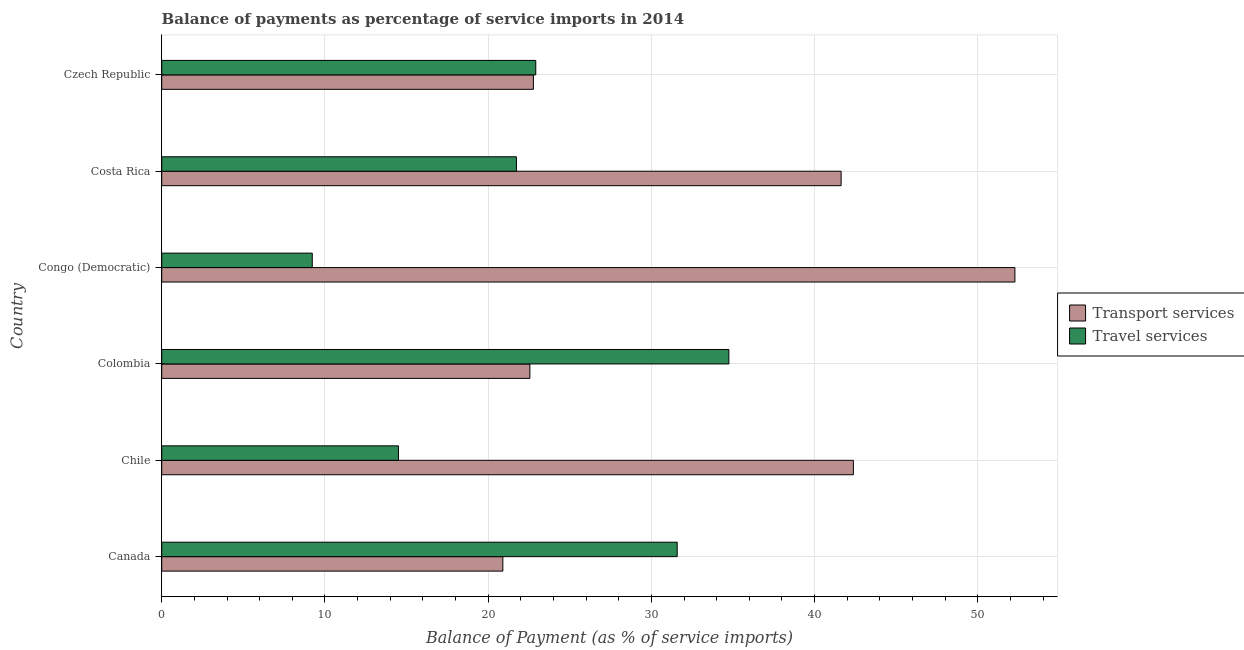How many different coloured bars are there?
Provide a short and direct response. 2. How many groups of bars are there?
Provide a short and direct response. 6. Are the number of bars on each tick of the Y-axis equal?
Offer a terse response. Yes. How many bars are there on the 6th tick from the bottom?
Your response must be concise. 2. In how many cases, is the number of bars for a given country not equal to the number of legend labels?
Offer a very short reply. 0. What is the balance of payments of transport services in Costa Rica?
Make the answer very short. 41.63. Across all countries, what is the maximum balance of payments of travel services?
Your answer should be very brief. 34.75. Across all countries, what is the minimum balance of payments of transport services?
Your answer should be very brief. 20.9. In which country was the balance of payments of transport services maximum?
Your response must be concise. Congo (Democratic). In which country was the balance of payments of transport services minimum?
Make the answer very short. Canada. What is the total balance of payments of transport services in the graph?
Provide a succinct answer. 202.5. What is the difference between the balance of payments of travel services in Chile and that in Colombia?
Keep it short and to the point. -20.24. What is the difference between the balance of payments of transport services in Costa Rica and the balance of payments of travel services in Chile?
Your answer should be compact. 27.12. What is the average balance of payments of transport services per country?
Your response must be concise. 33.75. What is the difference between the balance of payments of travel services and balance of payments of transport services in Congo (Democratic)?
Your answer should be very brief. -43.05. What is the ratio of the balance of payments of transport services in Canada to that in Czech Republic?
Your answer should be compact. 0.92. What is the difference between the highest and the second highest balance of payments of travel services?
Keep it short and to the point. 3.17. What is the difference between the highest and the lowest balance of payments of transport services?
Give a very brief answer. 31.37. Is the sum of the balance of payments of travel services in Canada and Colombia greater than the maximum balance of payments of transport services across all countries?
Offer a terse response. Yes. What does the 2nd bar from the top in Costa Rica represents?
Keep it short and to the point. Transport services. What does the 1st bar from the bottom in Canada represents?
Provide a succinct answer. Transport services. Are all the bars in the graph horizontal?
Your answer should be compact. Yes. How many countries are there in the graph?
Provide a short and direct response. 6. Are the values on the major ticks of X-axis written in scientific E-notation?
Give a very brief answer. No. Does the graph contain any zero values?
Your response must be concise. No. Does the graph contain grids?
Provide a succinct answer. Yes. How are the legend labels stacked?
Give a very brief answer. Vertical. What is the title of the graph?
Offer a terse response. Balance of payments as percentage of service imports in 2014. Does "Unregistered firms" appear as one of the legend labels in the graph?
Ensure brevity in your answer.  No. What is the label or title of the X-axis?
Offer a terse response. Balance of Payment (as % of service imports). What is the Balance of Payment (as % of service imports) of Transport services in Canada?
Keep it short and to the point. 20.9. What is the Balance of Payment (as % of service imports) of Travel services in Canada?
Your answer should be compact. 31.58. What is the Balance of Payment (as % of service imports) of Transport services in Chile?
Your answer should be very brief. 42.38. What is the Balance of Payment (as % of service imports) of Travel services in Chile?
Your response must be concise. 14.5. What is the Balance of Payment (as % of service imports) in Transport services in Colombia?
Give a very brief answer. 22.56. What is the Balance of Payment (as % of service imports) of Travel services in Colombia?
Provide a succinct answer. 34.75. What is the Balance of Payment (as % of service imports) of Transport services in Congo (Democratic)?
Offer a terse response. 52.27. What is the Balance of Payment (as % of service imports) of Travel services in Congo (Democratic)?
Make the answer very short. 9.22. What is the Balance of Payment (as % of service imports) of Transport services in Costa Rica?
Offer a very short reply. 41.63. What is the Balance of Payment (as % of service imports) in Travel services in Costa Rica?
Your answer should be compact. 21.73. What is the Balance of Payment (as % of service imports) in Transport services in Czech Republic?
Offer a very short reply. 22.77. What is the Balance of Payment (as % of service imports) of Travel services in Czech Republic?
Make the answer very short. 22.92. Across all countries, what is the maximum Balance of Payment (as % of service imports) of Transport services?
Offer a terse response. 52.27. Across all countries, what is the maximum Balance of Payment (as % of service imports) of Travel services?
Your response must be concise. 34.75. Across all countries, what is the minimum Balance of Payment (as % of service imports) in Transport services?
Keep it short and to the point. 20.9. Across all countries, what is the minimum Balance of Payment (as % of service imports) of Travel services?
Your answer should be compact. 9.22. What is the total Balance of Payment (as % of service imports) in Transport services in the graph?
Offer a very short reply. 202.5. What is the total Balance of Payment (as % of service imports) of Travel services in the graph?
Provide a succinct answer. 134.71. What is the difference between the Balance of Payment (as % of service imports) of Transport services in Canada and that in Chile?
Make the answer very short. -21.48. What is the difference between the Balance of Payment (as % of service imports) in Travel services in Canada and that in Chile?
Make the answer very short. 17.08. What is the difference between the Balance of Payment (as % of service imports) in Transport services in Canada and that in Colombia?
Provide a short and direct response. -1.66. What is the difference between the Balance of Payment (as % of service imports) of Travel services in Canada and that in Colombia?
Your answer should be very brief. -3.17. What is the difference between the Balance of Payment (as % of service imports) of Transport services in Canada and that in Congo (Democratic)?
Make the answer very short. -31.37. What is the difference between the Balance of Payment (as % of service imports) of Travel services in Canada and that in Congo (Democratic)?
Offer a terse response. 22.36. What is the difference between the Balance of Payment (as % of service imports) in Transport services in Canada and that in Costa Rica?
Give a very brief answer. -20.73. What is the difference between the Balance of Payment (as % of service imports) of Travel services in Canada and that in Costa Rica?
Your answer should be compact. 9.85. What is the difference between the Balance of Payment (as % of service imports) in Transport services in Canada and that in Czech Republic?
Give a very brief answer. -1.87. What is the difference between the Balance of Payment (as % of service imports) in Travel services in Canada and that in Czech Republic?
Provide a succinct answer. 8.66. What is the difference between the Balance of Payment (as % of service imports) in Transport services in Chile and that in Colombia?
Keep it short and to the point. 19.82. What is the difference between the Balance of Payment (as % of service imports) in Travel services in Chile and that in Colombia?
Your response must be concise. -20.24. What is the difference between the Balance of Payment (as % of service imports) in Transport services in Chile and that in Congo (Democratic)?
Give a very brief answer. -9.9. What is the difference between the Balance of Payment (as % of service imports) in Travel services in Chile and that in Congo (Democratic)?
Your answer should be very brief. 5.28. What is the difference between the Balance of Payment (as % of service imports) in Transport services in Chile and that in Costa Rica?
Keep it short and to the point. 0.75. What is the difference between the Balance of Payment (as % of service imports) of Travel services in Chile and that in Costa Rica?
Offer a very short reply. -7.23. What is the difference between the Balance of Payment (as % of service imports) in Transport services in Chile and that in Czech Republic?
Offer a very short reply. 19.6. What is the difference between the Balance of Payment (as % of service imports) of Travel services in Chile and that in Czech Republic?
Provide a succinct answer. -8.41. What is the difference between the Balance of Payment (as % of service imports) in Transport services in Colombia and that in Congo (Democratic)?
Offer a terse response. -29.72. What is the difference between the Balance of Payment (as % of service imports) of Travel services in Colombia and that in Congo (Democratic)?
Make the answer very short. 25.52. What is the difference between the Balance of Payment (as % of service imports) in Transport services in Colombia and that in Costa Rica?
Your answer should be compact. -19.07. What is the difference between the Balance of Payment (as % of service imports) in Travel services in Colombia and that in Costa Rica?
Give a very brief answer. 13.02. What is the difference between the Balance of Payment (as % of service imports) of Transport services in Colombia and that in Czech Republic?
Provide a short and direct response. -0.22. What is the difference between the Balance of Payment (as % of service imports) in Travel services in Colombia and that in Czech Republic?
Your answer should be compact. 11.83. What is the difference between the Balance of Payment (as % of service imports) of Transport services in Congo (Democratic) and that in Costa Rica?
Give a very brief answer. 10.65. What is the difference between the Balance of Payment (as % of service imports) in Travel services in Congo (Democratic) and that in Costa Rica?
Your answer should be very brief. -12.51. What is the difference between the Balance of Payment (as % of service imports) in Transport services in Congo (Democratic) and that in Czech Republic?
Your answer should be very brief. 29.5. What is the difference between the Balance of Payment (as % of service imports) in Travel services in Congo (Democratic) and that in Czech Republic?
Your answer should be very brief. -13.69. What is the difference between the Balance of Payment (as % of service imports) of Transport services in Costa Rica and that in Czech Republic?
Keep it short and to the point. 18.85. What is the difference between the Balance of Payment (as % of service imports) of Travel services in Costa Rica and that in Czech Republic?
Make the answer very short. -1.18. What is the difference between the Balance of Payment (as % of service imports) of Transport services in Canada and the Balance of Payment (as % of service imports) of Travel services in Chile?
Make the answer very short. 6.4. What is the difference between the Balance of Payment (as % of service imports) in Transport services in Canada and the Balance of Payment (as % of service imports) in Travel services in Colombia?
Your answer should be compact. -13.85. What is the difference between the Balance of Payment (as % of service imports) of Transport services in Canada and the Balance of Payment (as % of service imports) of Travel services in Congo (Democratic)?
Provide a succinct answer. 11.68. What is the difference between the Balance of Payment (as % of service imports) of Transport services in Canada and the Balance of Payment (as % of service imports) of Travel services in Costa Rica?
Keep it short and to the point. -0.83. What is the difference between the Balance of Payment (as % of service imports) in Transport services in Canada and the Balance of Payment (as % of service imports) in Travel services in Czech Republic?
Provide a short and direct response. -2.02. What is the difference between the Balance of Payment (as % of service imports) in Transport services in Chile and the Balance of Payment (as % of service imports) in Travel services in Colombia?
Provide a short and direct response. 7.63. What is the difference between the Balance of Payment (as % of service imports) of Transport services in Chile and the Balance of Payment (as % of service imports) of Travel services in Congo (Democratic)?
Your answer should be very brief. 33.15. What is the difference between the Balance of Payment (as % of service imports) in Transport services in Chile and the Balance of Payment (as % of service imports) in Travel services in Costa Rica?
Offer a very short reply. 20.64. What is the difference between the Balance of Payment (as % of service imports) in Transport services in Chile and the Balance of Payment (as % of service imports) in Travel services in Czech Republic?
Your answer should be very brief. 19.46. What is the difference between the Balance of Payment (as % of service imports) of Transport services in Colombia and the Balance of Payment (as % of service imports) of Travel services in Congo (Democratic)?
Give a very brief answer. 13.33. What is the difference between the Balance of Payment (as % of service imports) of Transport services in Colombia and the Balance of Payment (as % of service imports) of Travel services in Costa Rica?
Provide a short and direct response. 0.82. What is the difference between the Balance of Payment (as % of service imports) of Transport services in Colombia and the Balance of Payment (as % of service imports) of Travel services in Czech Republic?
Make the answer very short. -0.36. What is the difference between the Balance of Payment (as % of service imports) in Transport services in Congo (Democratic) and the Balance of Payment (as % of service imports) in Travel services in Costa Rica?
Give a very brief answer. 30.54. What is the difference between the Balance of Payment (as % of service imports) in Transport services in Congo (Democratic) and the Balance of Payment (as % of service imports) in Travel services in Czech Republic?
Offer a very short reply. 29.36. What is the difference between the Balance of Payment (as % of service imports) in Transport services in Costa Rica and the Balance of Payment (as % of service imports) in Travel services in Czech Republic?
Give a very brief answer. 18.71. What is the average Balance of Payment (as % of service imports) in Transport services per country?
Your answer should be compact. 33.75. What is the average Balance of Payment (as % of service imports) of Travel services per country?
Your answer should be very brief. 22.45. What is the difference between the Balance of Payment (as % of service imports) in Transport services and Balance of Payment (as % of service imports) in Travel services in Canada?
Give a very brief answer. -10.68. What is the difference between the Balance of Payment (as % of service imports) of Transport services and Balance of Payment (as % of service imports) of Travel services in Chile?
Make the answer very short. 27.87. What is the difference between the Balance of Payment (as % of service imports) of Transport services and Balance of Payment (as % of service imports) of Travel services in Colombia?
Offer a very short reply. -12.19. What is the difference between the Balance of Payment (as % of service imports) in Transport services and Balance of Payment (as % of service imports) in Travel services in Congo (Democratic)?
Offer a very short reply. 43.05. What is the difference between the Balance of Payment (as % of service imports) in Transport services and Balance of Payment (as % of service imports) in Travel services in Costa Rica?
Your answer should be compact. 19.89. What is the difference between the Balance of Payment (as % of service imports) in Transport services and Balance of Payment (as % of service imports) in Travel services in Czech Republic?
Your answer should be compact. -0.14. What is the ratio of the Balance of Payment (as % of service imports) of Transport services in Canada to that in Chile?
Your answer should be very brief. 0.49. What is the ratio of the Balance of Payment (as % of service imports) in Travel services in Canada to that in Chile?
Offer a terse response. 2.18. What is the ratio of the Balance of Payment (as % of service imports) of Transport services in Canada to that in Colombia?
Give a very brief answer. 0.93. What is the ratio of the Balance of Payment (as % of service imports) of Travel services in Canada to that in Colombia?
Provide a succinct answer. 0.91. What is the ratio of the Balance of Payment (as % of service imports) of Transport services in Canada to that in Congo (Democratic)?
Provide a succinct answer. 0.4. What is the ratio of the Balance of Payment (as % of service imports) of Travel services in Canada to that in Congo (Democratic)?
Your response must be concise. 3.42. What is the ratio of the Balance of Payment (as % of service imports) in Transport services in Canada to that in Costa Rica?
Ensure brevity in your answer.  0.5. What is the ratio of the Balance of Payment (as % of service imports) in Travel services in Canada to that in Costa Rica?
Ensure brevity in your answer.  1.45. What is the ratio of the Balance of Payment (as % of service imports) in Transport services in Canada to that in Czech Republic?
Offer a very short reply. 0.92. What is the ratio of the Balance of Payment (as % of service imports) of Travel services in Canada to that in Czech Republic?
Keep it short and to the point. 1.38. What is the ratio of the Balance of Payment (as % of service imports) in Transport services in Chile to that in Colombia?
Your answer should be compact. 1.88. What is the ratio of the Balance of Payment (as % of service imports) in Travel services in Chile to that in Colombia?
Provide a short and direct response. 0.42. What is the ratio of the Balance of Payment (as % of service imports) in Transport services in Chile to that in Congo (Democratic)?
Make the answer very short. 0.81. What is the ratio of the Balance of Payment (as % of service imports) of Travel services in Chile to that in Congo (Democratic)?
Offer a terse response. 1.57. What is the ratio of the Balance of Payment (as % of service imports) of Transport services in Chile to that in Costa Rica?
Keep it short and to the point. 1.02. What is the ratio of the Balance of Payment (as % of service imports) in Travel services in Chile to that in Costa Rica?
Your answer should be very brief. 0.67. What is the ratio of the Balance of Payment (as % of service imports) in Transport services in Chile to that in Czech Republic?
Keep it short and to the point. 1.86. What is the ratio of the Balance of Payment (as % of service imports) in Travel services in Chile to that in Czech Republic?
Make the answer very short. 0.63. What is the ratio of the Balance of Payment (as % of service imports) in Transport services in Colombia to that in Congo (Democratic)?
Keep it short and to the point. 0.43. What is the ratio of the Balance of Payment (as % of service imports) of Travel services in Colombia to that in Congo (Democratic)?
Give a very brief answer. 3.77. What is the ratio of the Balance of Payment (as % of service imports) of Transport services in Colombia to that in Costa Rica?
Provide a short and direct response. 0.54. What is the ratio of the Balance of Payment (as % of service imports) in Travel services in Colombia to that in Costa Rica?
Give a very brief answer. 1.6. What is the ratio of the Balance of Payment (as % of service imports) in Transport services in Colombia to that in Czech Republic?
Your answer should be very brief. 0.99. What is the ratio of the Balance of Payment (as % of service imports) in Travel services in Colombia to that in Czech Republic?
Offer a terse response. 1.52. What is the ratio of the Balance of Payment (as % of service imports) of Transport services in Congo (Democratic) to that in Costa Rica?
Ensure brevity in your answer.  1.26. What is the ratio of the Balance of Payment (as % of service imports) in Travel services in Congo (Democratic) to that in Costa Rica?
Your answer should be compact. 0.42. What is the ratio of the Balance of Payment (as % of service imports) in Transport services in Congo (Democratic) to that in Czech Republic?
Provide a succinct answer. 2.3. What is the ratio of the Balance of Payment (as % of service imports) of Travel services in Congo (Democratic) to that in Czech Republic?
Your response must be concise. 0.4. What is the ratio of the Balance of Payment (as % of service imports) in Transport services in Costa Rica to that in Czech Republic?
Provide a short and direct response. 1.83. What is the ratio of the Balance of Payment (as % of service imports) of Travel services in Costa Rica to that in Czech Republic?
Your answer should be compact. 0.95. What is the difference between the highest and the second highest Balance of Payment (as % of service imports) of Transport services?
Your answer should be very brief. 9.9. What is the difference between the highest and the second highest Balance of Payment (as % of service imports) in Travel services?
Your response must be concise. 3.17. What is the difference between the highest and the lowest Balance of Payment (as % of service imports) in Transport services?
Your response must be concise. 31.37. What is the difference between the highest and the lowest Balance of Payment (as % of service imports) of Travel services?
Keep it short and to the point. 25.52. 